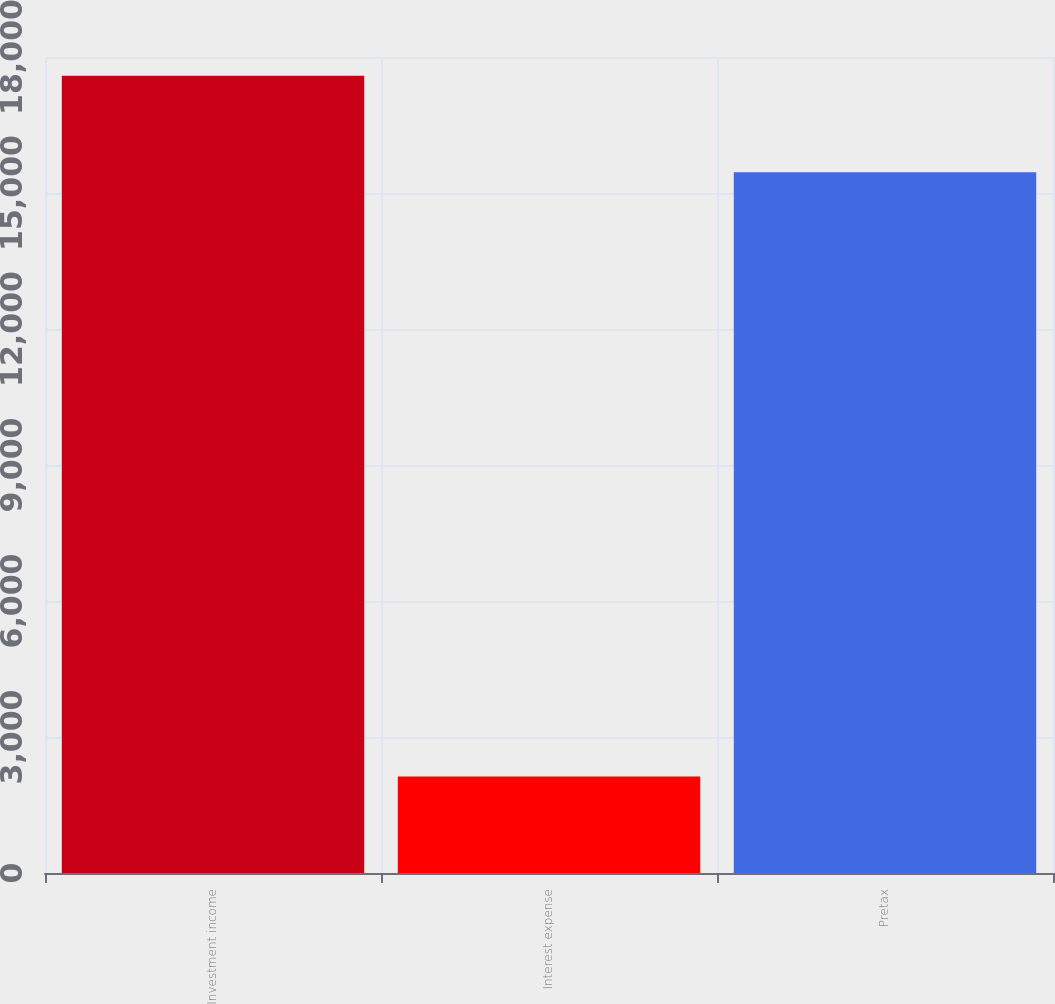Convert chart. <chart><loc_0><loc_0><loc_500><loc_500><bar_chart><fcel>Investment income<fcel>Interest expense<fcel>Pretax<nl><fcel>17588<fcel>2128<fcel>15460<nl></chart> 